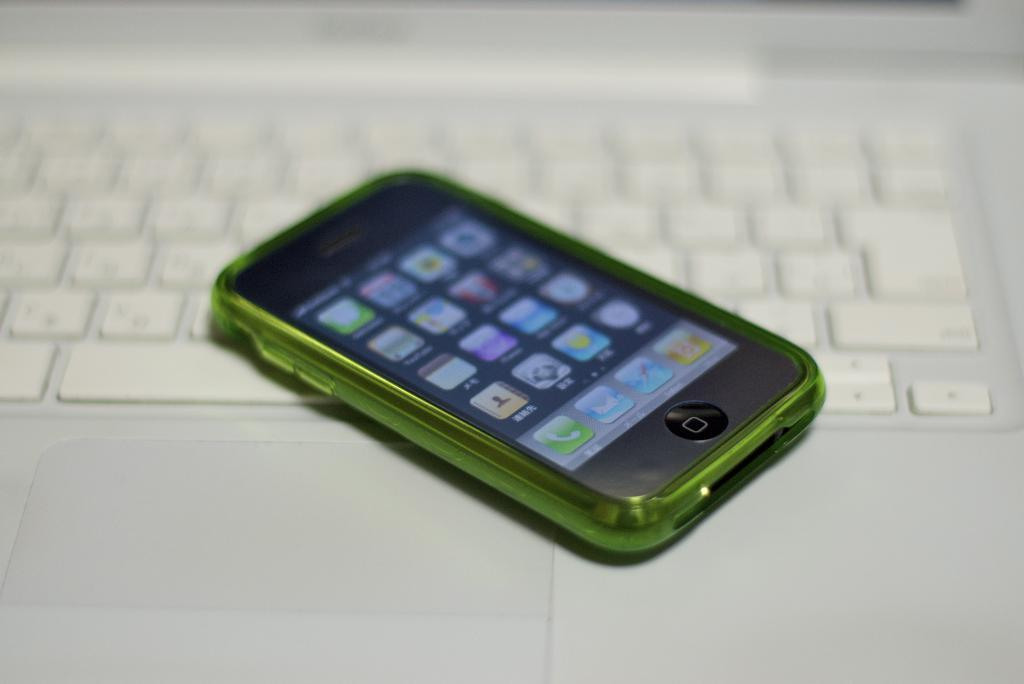What object is present on a white-colored keyboard in the image? There is a mobile on a white-colored keyboard in the image. What can be seen on the mobile screen? There are icons visible on the mobile screen. What type of spy equipment is hidden inside the mobile in the image? There is no indication in the image that the mobile contains any spy equipment. 